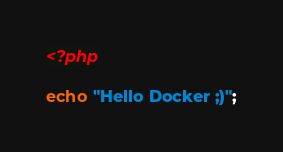<code> <loc_0><loc_0><loc_500><loc_500><_PHP_><?php

echo "Hello Docker ;)";
</code> 